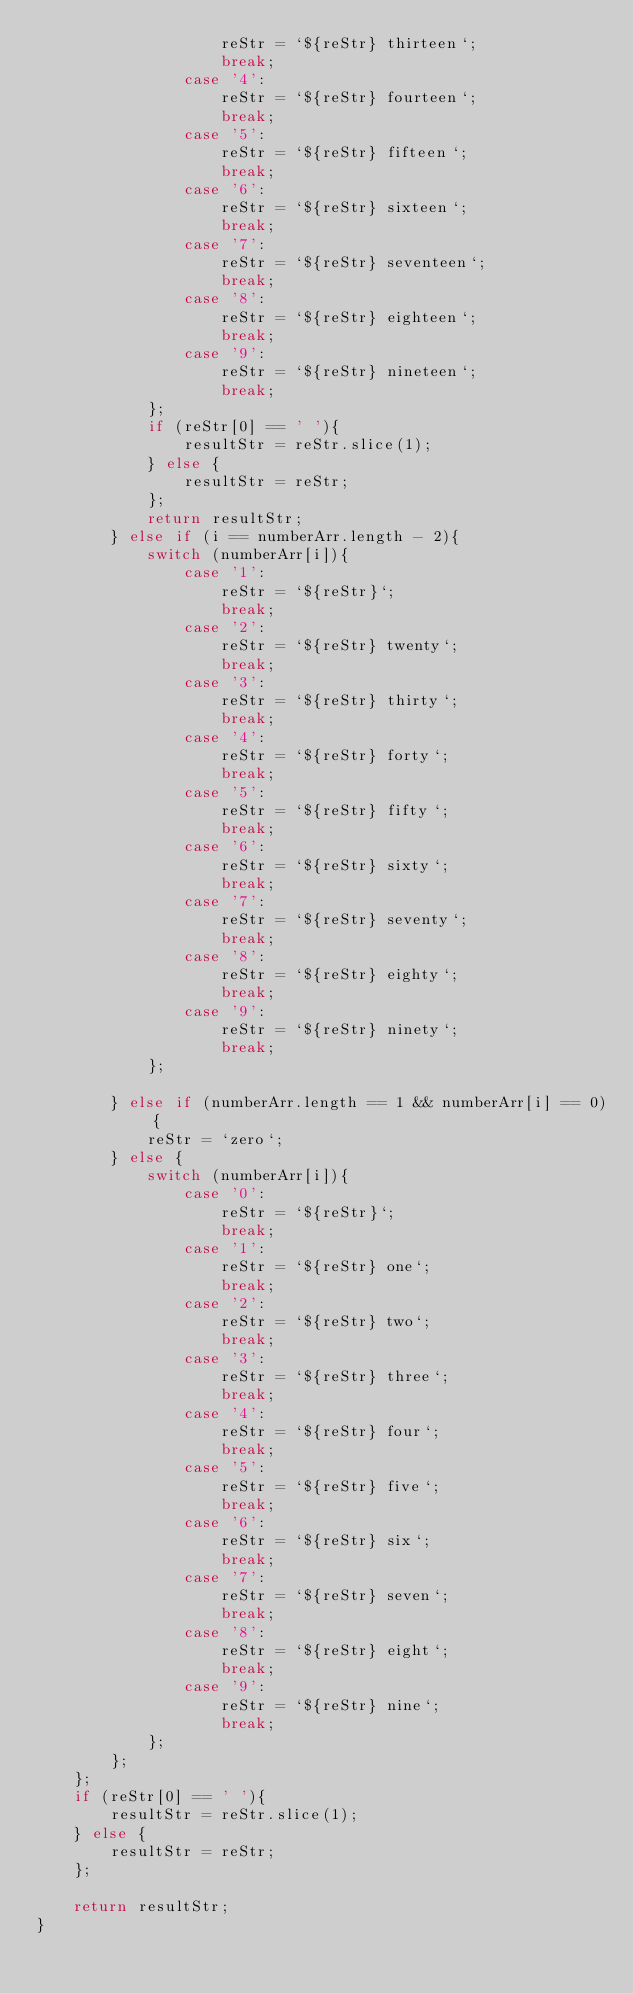<code> <loc_0><loc_0><loc_500><loc_500><_JavaScript_>                    reStr = `${reStr} thirteen`;
                    break;
                case '4':
                    reStr = `${reStr} fourteen`;
                    break;
                case '5':
                    reStr = `${reStr} fifteen`;
                    break;
                case '6':
                    reStr = `${reStr} sixteen`;
                    break;
                case '7':
                    reStr = `${reStr} seventeen`;
                    break;
                case '8':
                    reStr = `${reStr} eighteen`;
                    break;
                case '9':
                    reStr = `${reStr} nineteen`;
                    break;
            };
            if (reStr[0] == ' '){
                resultStr = reStr.slice(1);
            } else {
                resultStr = reStr;
            };
            return resultStr;
        } else if (i == numberArr.length - 2){
            switch (numberArr[i]){
                case '1':
                    reStr = `${reStr}`;
                    break;
                case '2':
                    reStr = `${reStr} twenty`;
                    break;
                case '3':
                    reStr = `${reStr} thirty`;
                    break;
                case '4':
                    reStr = `${reStr} forty`;
                    break;
                case '5':
                    reStr = `${reStr} fifty`;
                    break;
                case '6':
                    reStr = `${reStr} sixty`;
                    break;
                case '7':
                    reStr = `${reStr} seventy`;
                    break;
                case '8':
                    reStr = `${reStr} eighty`;
                    break;
                case '9':
                    reStr = `${reStr} ninety`;
                    break;
            };

        } else if (numberArr.length == 1 && numberArr[i] == 0) {
            reStr = `zero`;
        } else {
            switch (numberArr[i]){
                case '0':
                    reStr = `${reStr}`;
                    break;
                case '1':
                    reStr = `${reStr} one`;
                    break;
                case '2':
                    reStr = `${reStr} two`;
                    break;
                case '3':
                    reStr = `${reStr} three`;
                    break;
                case '4':
                    reStr = `${reStr} four`;
                    break;
                case '5':
                    reStr = `${reStr} five`;
                    break;
                case '6':
                    reStr = `${reStr} six`;
                    break;
                case '7':
                    reStr = `${reStr} seven`;
                    break;
                case '8':
                    reStr = `${reStr} eight`;
                    break;
                case '9':
                    reStr = `${reStr} nine`;
                    break;
            };
        };
    };
    if (reStr[0] == ' '){
        resultStr = reStr.slice(1);
    } else {
        resultStr = reStr;
    };

    return resultStr;
}
</code> 